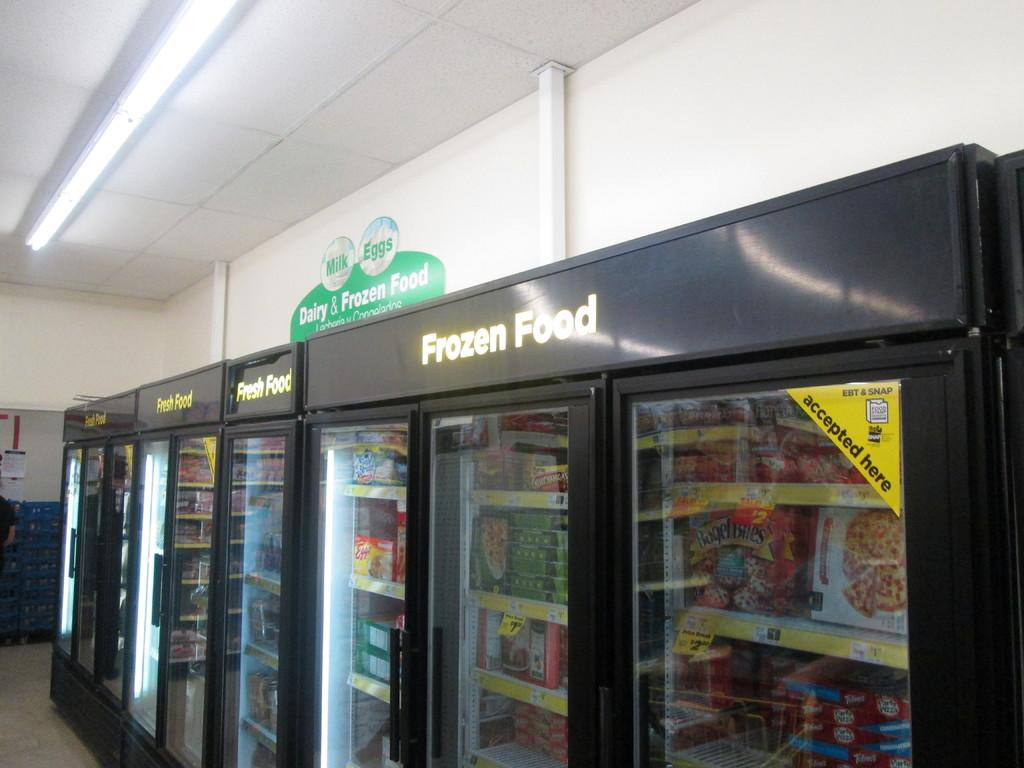<image>
Summarize the visual content of the image. A frozen food sign hangs next to a fresh food sign. 